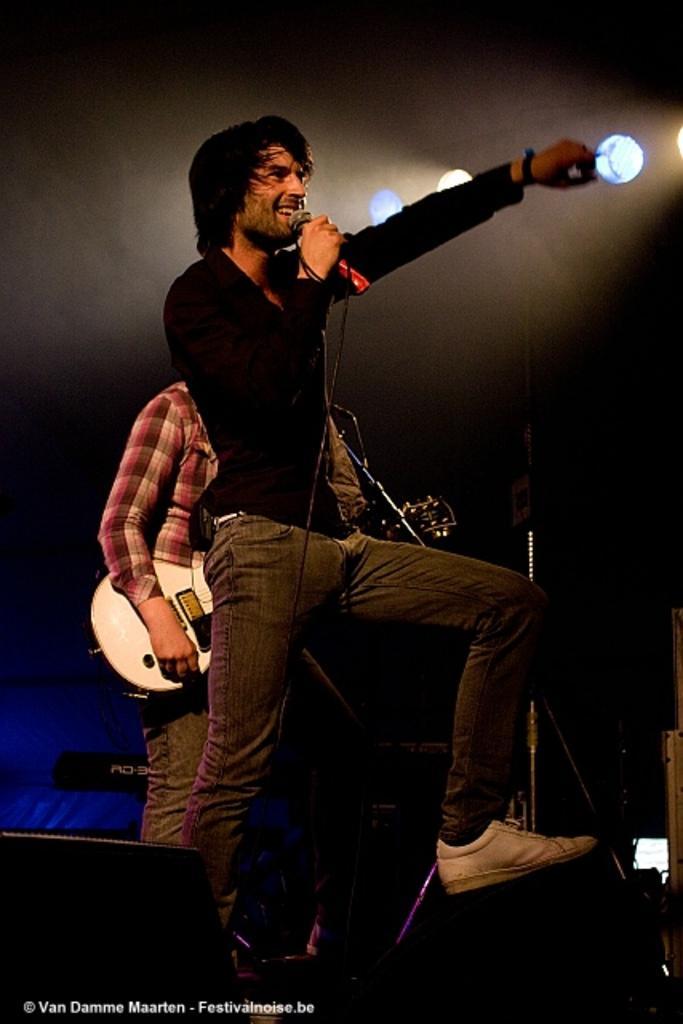Can you describe this image briefly? A man holding a mic,pointing at the audience raises hand. He holds mic with a right hand and he also raises his left leg. Behind him there is a guitarist playing the guitar. In front of the singer there is a speaker. On the top there are lights which are pointing at the singer. 